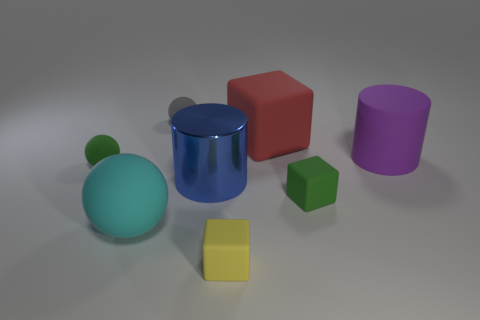Add 1 large things. How many objects exist? 9 Subtract all blocks. How many objects are left? 5 Add 4 large red rubber objects. How many large red rubber objects are left? 5 Add 4 cyan spheres. How many cyan spheres exist? 5 Subtract 1 gray spheres. How many objects are left? 7 Subtract all tiny purple metallic cylinders. Subtract all green balls. How many objects are left? 7 